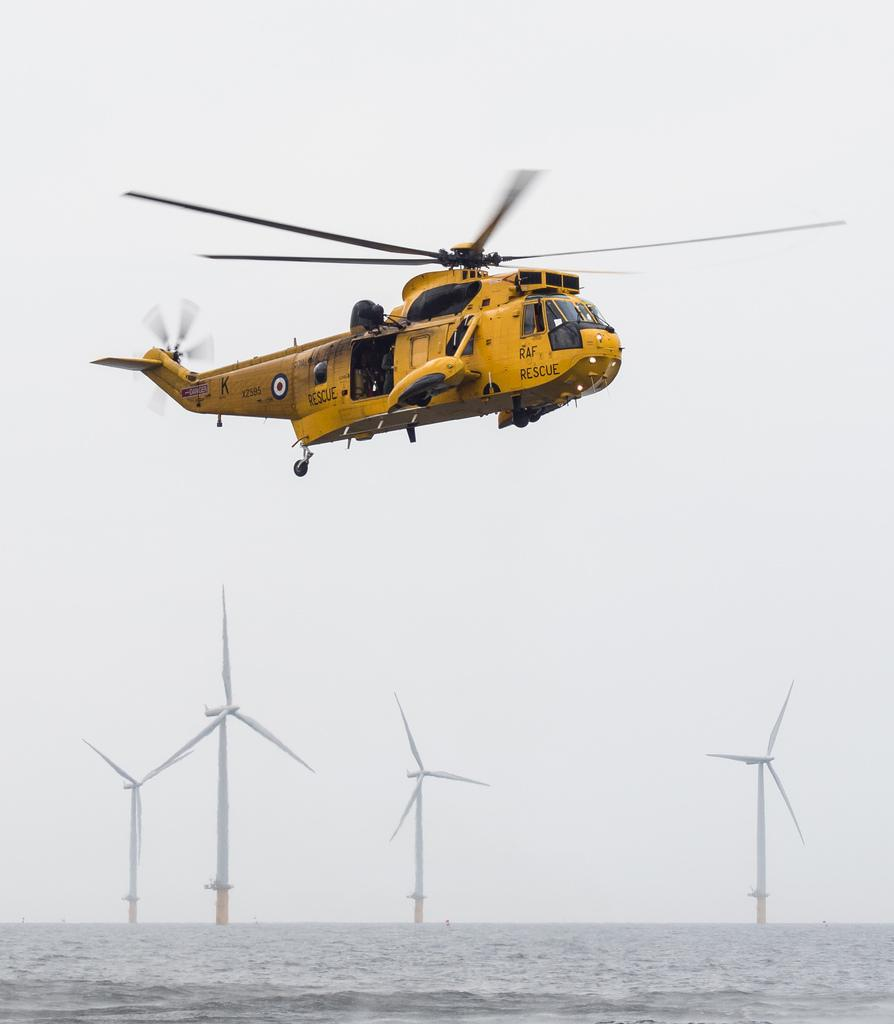What is the main subject of the image? The main subject of the image is a helicopter. What is the helicopter doing in the image? The helicopter is flying in the sky. What can be seen at the bottom of the image? There is water visible at the bottom of the image. What other structures are present in the image? There are windmills in the image. What type of pet can be seen playing with cherries in the image? There is no pet or cherries present in the image; it features a helicopter flying in the sky and windmills. What kind of bird is perched on the wren in the image? There is no bird or wren present in the image. 